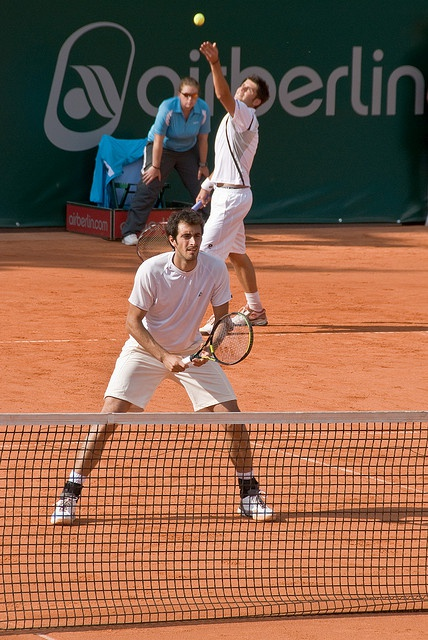Describe the objects in this image and their specific colors. I can see people in black, darkgray, gray, lightgray, and maroon tones, people in black, darkgray, white, and brown tones, people in black, blue, gray, and teal tones, chair in black, teal, and blue tones, and tennis racket in black, salmon, brown, and maroon tones in this image. 